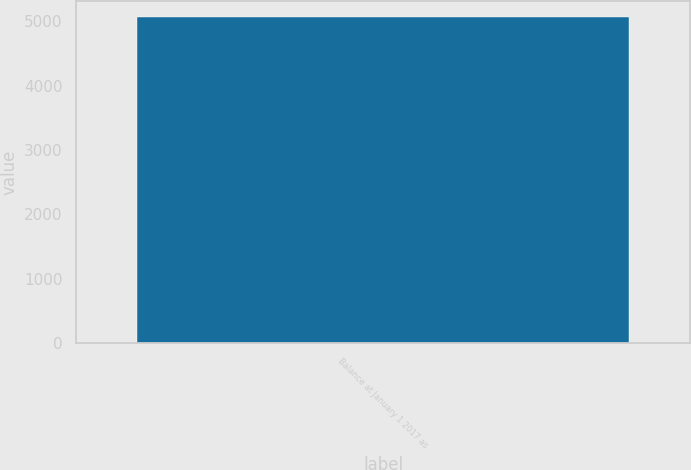Convert chart to OTSL. <chart><loc_0><loc_0><loc_500><loc_500><bar_chart><fcel>Balance at January 1 2017 as<nl><fcel>5061.1<nl></chart> 